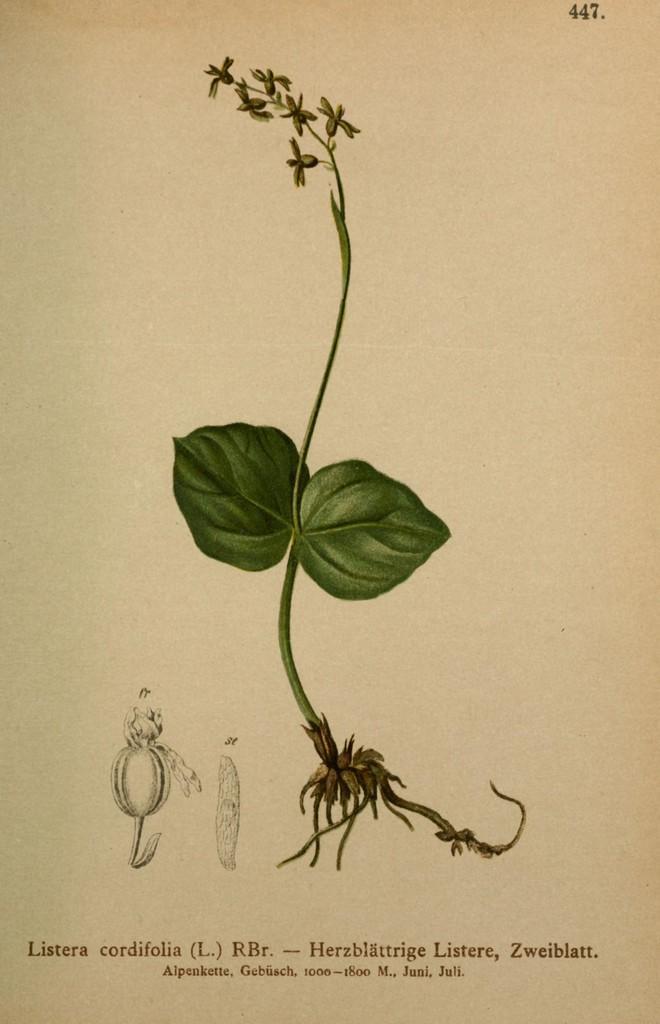How would you summarize this image in a sentence or two? In this picture we can see some information on a paper. We can see a plant and leaves. 